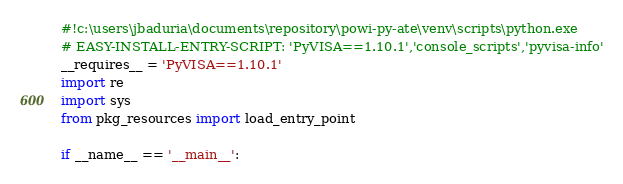<code> <loc_0><loc_0><loc_500><loc_500><_Python_>#!c:\users\jbaduria\documents\repository\powi-py-ate\venv\scripts\python.exe
# EASY-INSTALL-ENTRY-SCRIPT: 'PyVISA==1.10.1','console_scripts','pyvisa-info'
__requires__ = 'PyVISA==1.10.1'
import re
import sys
from pkg_resources import load_entry_point

if __name__ == '__main__':</code> 